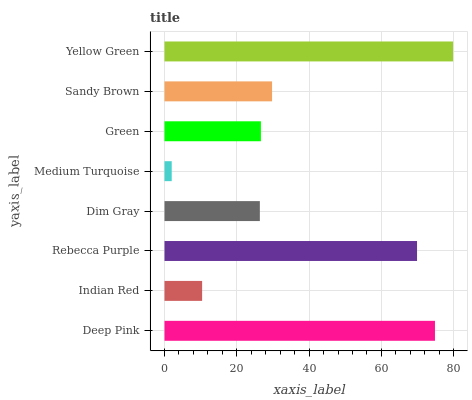Is Medium Turquoise the minimum?
Answer yes or no. Yes. Is Yellow Green the maximum?
Answer yes or no. Yes. Is Indian Red the minimum?
Answer yes or no. No. Is Indian Red the maximum?
Answer yes or no. No. Is Deep Pink greater than Indian Red?
Answer yes or no. Yes. Is Indian Red less than Deep Pink?
Answer yes or no. Yes. Is Indian Red greater than Deep Pink?
Answer yes or no. No. Is Deep Pink less than Indian Red?
Answer yes or no. No. Is Sandy Brown the high median?
Answer yes or no. Yes. Is Green the low median?
Answer yes or no. Yes. Is Green the high median?
Answer yes or no. No. Is Sandy Brown the low median?
Answer yes or no. No. 